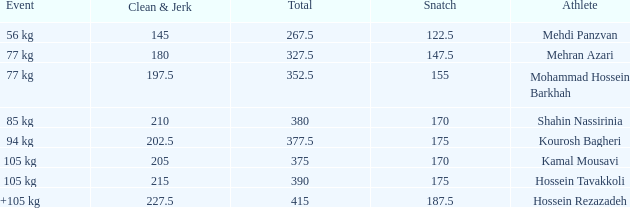How many snatches were there with a total of 267.5? 0.0. 